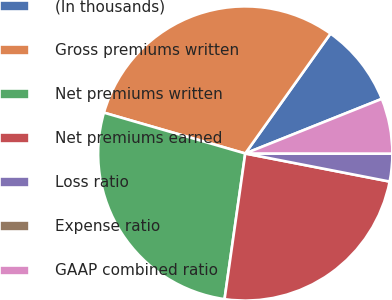<chart> <loc_0><loc_0><loc_500><loc_500><pie_chart><fcel>(In thousands)<fcel>Gross premiums written<fcel>Net premiums written<fcel>Net premiums earned<fcel>Loss ratio<fcel>Expense ratio<fcel>GAAP combined ratio<nl><fcel>9.11%<fcel>30.36%<fcel>27.23%<fcel>24.19%<fcel>3.04%<fcel>0.0%<fcel>6.07%<nl></chart> 